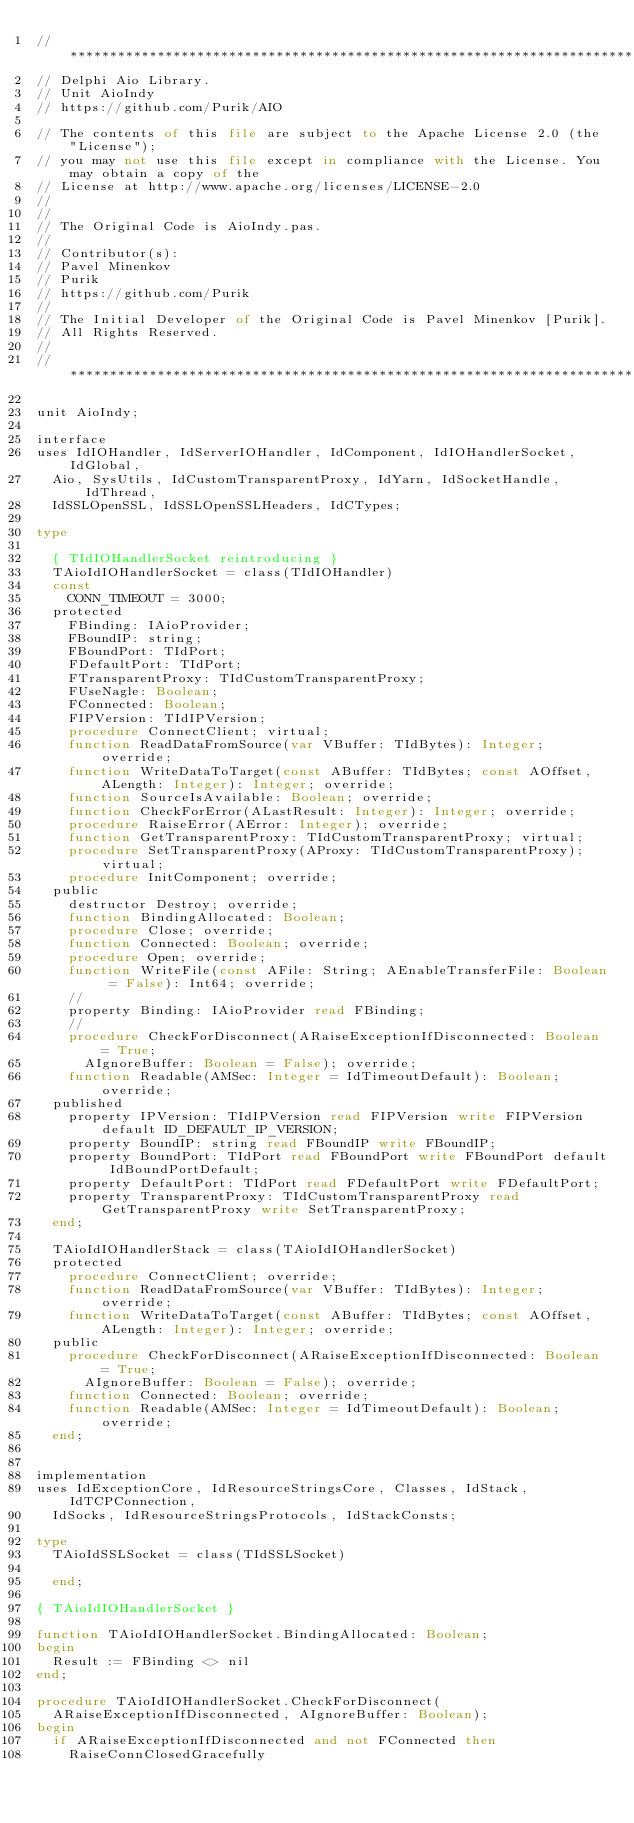Convert code to text. <code><loc_0><loc_0><loc_500><loc_500><_Pascal_>// **************************************************************************************************
// Delphi Aio Library.
// Unit AioIndy
// https://github.com/Purik/AIO

// The contents of this file are subject to the Apache License 2.0 (the "License");
// you may not use this file except in compliance with the License. You may obtain a copy of the
// License at http://www.apache.org/licenses/LICENSE-2.0
//
//
// The Original Code is AioIndy.pas.
//
// Contributor(s):
// Pavel Minenkov
// Purik
// https://github.com/Purik
//
// The Initial Developer of the Original Code is Pavel Minenkov [Purik].
// All Rights Reserved.
//
// **************************************************************************************************

unit AioIndy;

interface
uses IdIOHandler, IdServerIOHandler, IdComponent, IdIOHandlerSocket, IdGlobal,
  Aio, SysUtils, IdCustomTransparentProxy, IdYarn, IdSocketHandle, IdThread,
  IdSSLOpenSSL, IdSSLOpenSSLHeaders, IdCTypes;

type

  { TIdIOHandlerSocket reintroducing }
  TAioIdIOHandlerSocket = class(TIdIOHandler)
  const
    CONN_TIMEOUT = 3000;
  protected
    FBinding: IAioProvider;
    FBoundIP: string;
    FBoundPort: TIdPort;
    FDefaultPort: TIdPort;
    FTransparentProxy: TIdCustomTransparentProxy;
    FUseNagle: Boolean;
    FConnected: Boolean;
    FIPVersion: TIdIPVersion;
    procedure ConnectClient; virtual;
    function ReadDataFromSource(var VBuffer: TIdBytes): Integer; override;
    function WriteDataToTarget(const ABuffer: TIdBytes; const AOffset, ALength: Integer): Integer; override;
    function SourceIsAvailable: Boolean; override;
    function CheckForError(ALastResult: Integer): Integer; override;
    procedure RaiseError(AError: Integer); override;
    function GetTransparentProxy: TIdCustomTransparentProxy; virtual;
    procedure SetTransparentProxy(AProxy: TIdCustomTransparentProxy); virtual;
    procedure InitComponent; override;
  public
    destructor Destroy; override;
    function BindingAllocated: Boolean;
    procedure Close; override;
    function Connected: Boolean; override;
    procedure Open; override;
    function WriteFile(const AFile: String; AEnableTransferFile: Boolean = False): Int64; override;
    //
    property Binding: IAioProvider read FBinding;
    //
    procedure CheckForDisconnect(ARaiseExceptionIfDisconnected: Boolean = True;
      AIgnoreBuffer: Boolean = False); override;
    function Readable(AMSec: Integer = IdTimeoutDefault): Boolean; override;
  published
    property IPVersion: TIdIPVersion read FIPVersion write FIPVersion default ID_DEFAULT_IP_VERSION;
    property BoundIP: string read FBoundIP write FBoundIP;
    property BoundPort: TIdPort read FBoundPort write FBoundPort default IdBoundPortDefault;
    property DefaultPort: TIdPort read FDefaultPort write FDefaultPort;
    property TransparentProxy: TIdCustomTransparentProxy read GetTransparentProxy write SetTransparentProxy;
  end;

  TAioIdIOHandlerStack = class(TAioIdIOHandlerSocket)
  protected
    procedure ConnectClient; override;
    function ReadDataFromSource(var VBuffer: TIdBytes): Integer; override;
    function WriteDataToTarget(const ABuffer: TIdBytes; const AOffset, ALength: Integer): Integer; override;
  public
    procedure CheckForDisconnect(ARaiseExceptionIfDisconnected: Boolean = True;
      AIgnoreBuffer: Boolean = False); override;
    function Connected: Boolean; override;
    function Readable(AMSec: Integer = IdTimeoutDefault): Boolean; override;
  end;


implementation
uses IdExceptionCore, IdResourceStringsCore, Classes, IdStack, IdTCPConnection,
  IdSocks, IdResourceStringsProtocols, IdStackConsts;

type
  TAioIdSSLSocket = class(TIdSSLSocket)

  end;

{ TAioIdIOHandlerSocket }

function TAioIdIOHandlerSocket.BindingAllocated: Boolean;
begin
  Result := FBinding <> nil
end;

procedure TAioIdIOHandlerSocket.CheckForDisconnect(
  ARaiseExceptionIfDisconnected, AIgnoreBuffer: Boolean);
begin
  if ARaiseExceptionIfDisconnected and not FConnected then
    RaiseConnClosedGracefully</code> 